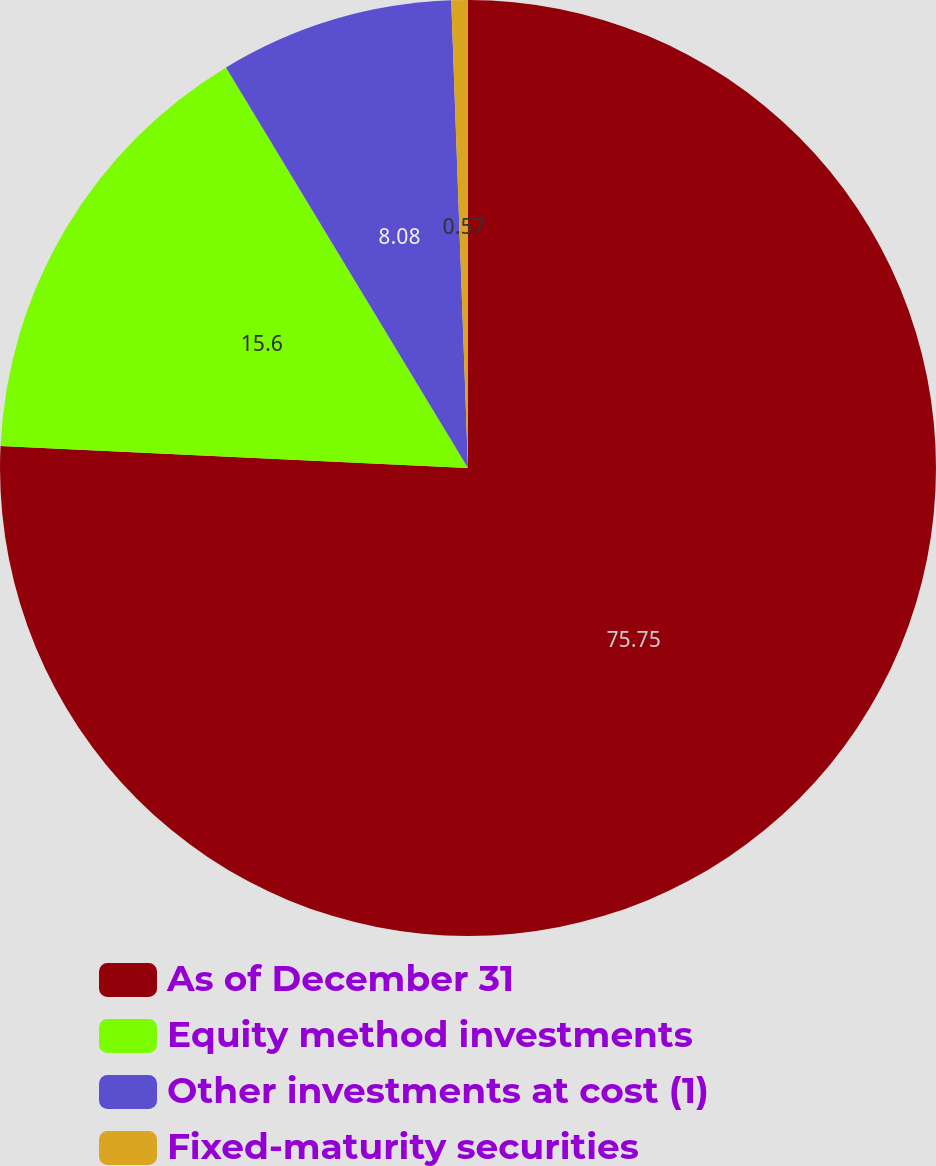Convert chart. <chart><loc_0><loc_0><loc_500><loc_500><pie_chart><fcel>As of December 31<fcel>Equity method investments<fcel>Other investments at cost (1)<fcel>Fixed-maturity securities<nl><fcel>75.75%<fcel>15.6%<fcel>8.08%<fcel>0.57%<nl></chart> 